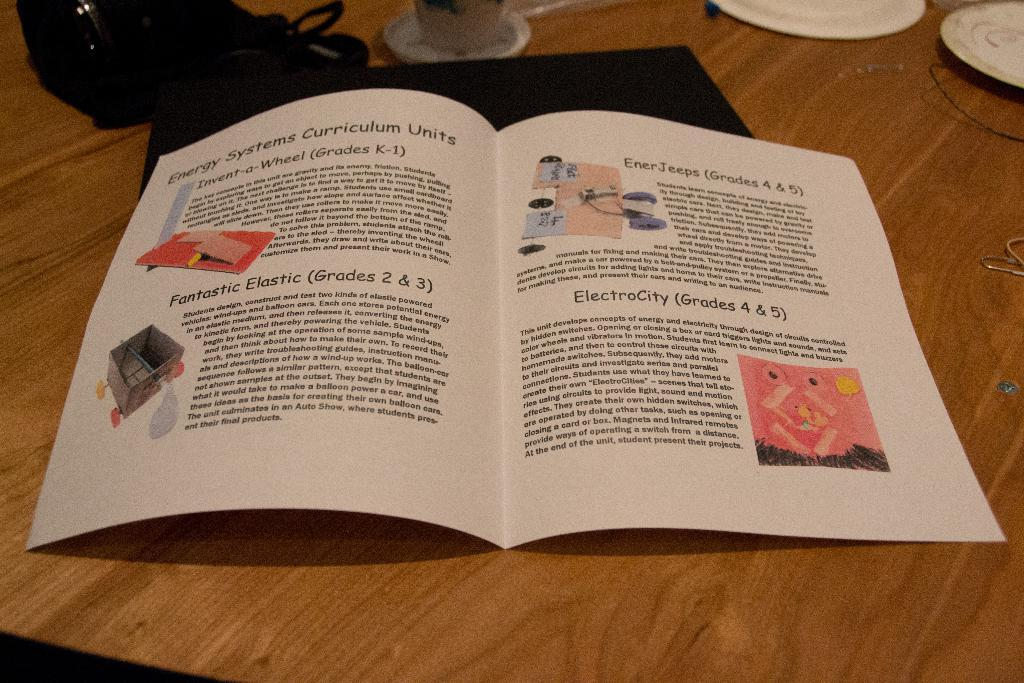Provide a one-sentence caption for the provided image. Energy Systems Curriculum Units included Invent-a-Wheel (Grades K-1), Fantastic Elastic (Grades 2 & 3), EnerJeeps (Grades 4 & 5), and ElectroCity (Grades 4 & 5). 